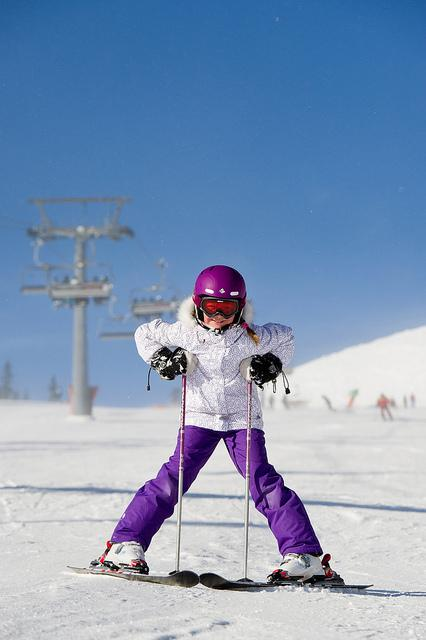What is the girl using the poles to do? Please explain your reasoning. stand up. The girl is heavily putting her weight on the poles, and her legs aren't positioned to support her. 